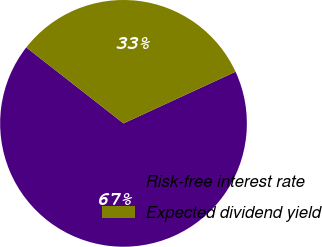<chart> <loc_0><loc_0><loc_500><loc_500><pie_chart><fcel>Risk-free interest rate<fcel>Expected dividend yield<nl><fcel>67.43%<fcel>32.57%<nl></chart> 